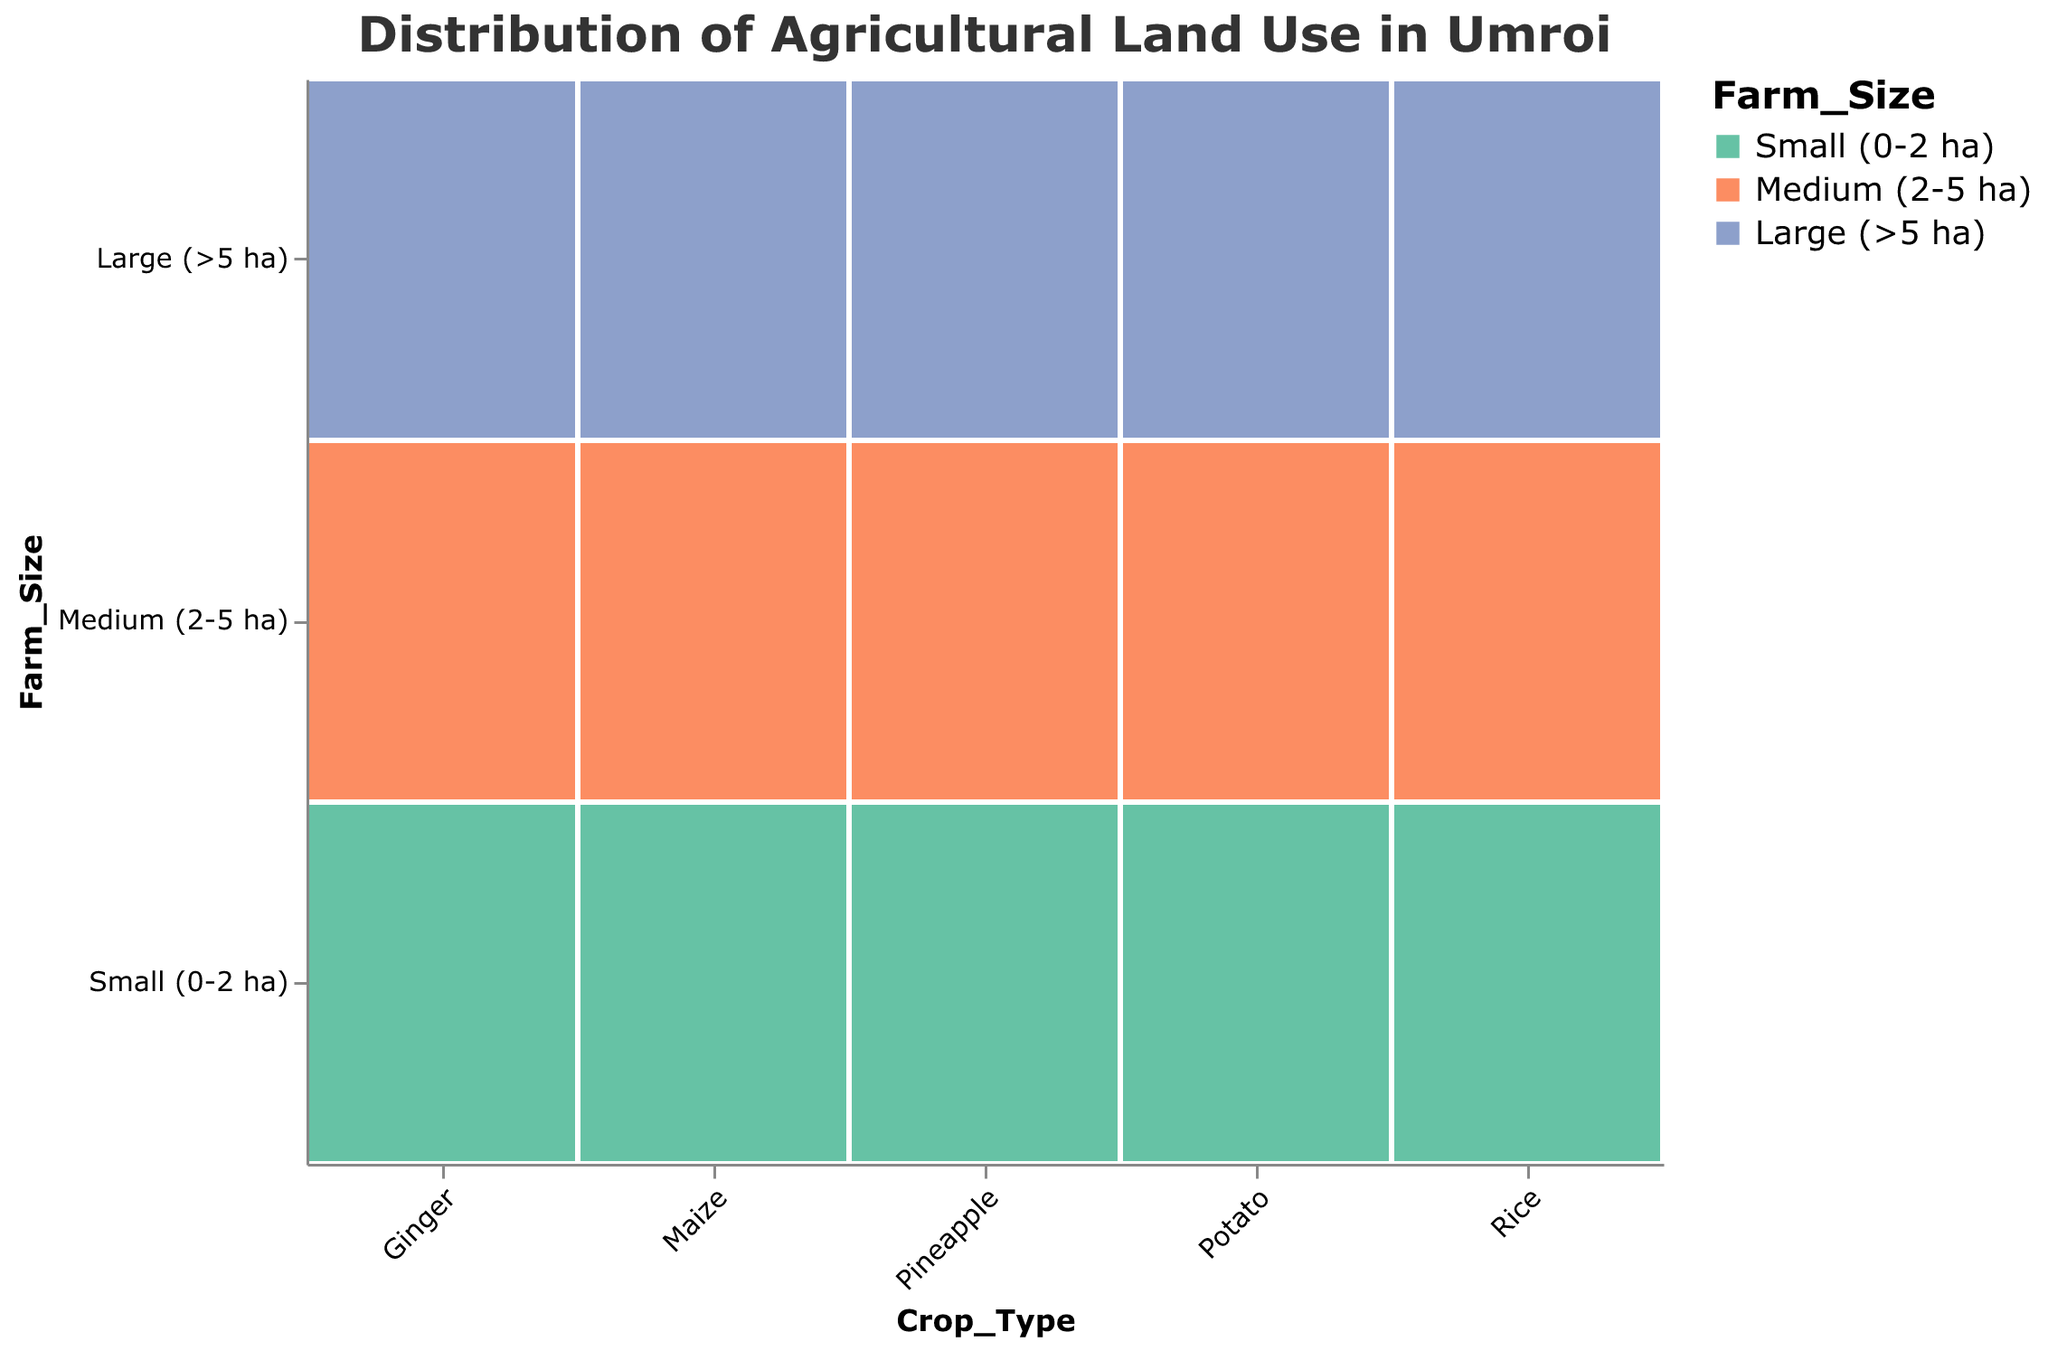What is the title of the figure? The title can be found at the top of the figure and serves to inform the viewer of the main focus of the visual representation.
Answer: Distribution of Agricultural Land Use in Umroi Which crop type has the largest area of agricultural land for small farms (0-2 ha)? By examining each crop type and the corresponding section for small farms, we see that Rice has the largest area (450 hectares).
Answer: Rice How much more area is used for medium farms (2-5 ha) compared to large farms (>5 ha) for Rice? The area used for medium farms is 680 hectares and for large farms, it is 320 hectares. Subtract 320 from 680 to get the difference.
Answer: 360 hectares Which crop type has the least area in large farms (>5 ha)? Compare the areas of large farms for all crop types and identify the smallest value. Ginger has the smallest area at 40 hectares.
Answer: Ginger What's the total area used for growing Maize across all farm sizes? Add the areas for small (180 ha), medium (240 ha), and large farms (130 ha) to get the total.
Answer: 550 hectares Which farm size category uses the maximum area for growing Ginger? Compare the areas of small, medium, and large farm sizes for Ginger. The small farm size category has the maximum area at 120 hectares.
Answer: Small (0-2 ha) Which crop type utilizes a larger area for small farms (0-2 ha) than medium farms (2-5 ha)? Examine the areas of small and medium farm sizes for each crop. Rice (450 ha vs. 680 ha) and Potato (220 ha vs. 180 ha) are the only crops having larger areas for small farms compared to medium farms. Therefore, Potato is the correct crop type.
Answer: Potato What is the total agricultural area used for Pineapple farming? Sum the areas for small (90 ha), medium (110 ha), and large farms (70 ha).
Answer: 270 hectares Rank the crop types by total area used from highest to lowest. Calculate the total area for each crop and rank them. Rice: 1450 ha, Maize: 550 ha, Potato: 490 ha, Pineapple: 270 ha, Ginger: 240 ha. Therefore, the ranking is Rice, Maize, Potato, Pineapple, Ginger.
Answer: Rice, Maize, Potato, Pineapple, Ginger Is there any crop type where large farms (>5 ha) cover more area than small farms (0-2 ha)? By examining each crop type, we observe that none of the crops has large farms covering more area than small farms. All crop types have larger or equal areas for small farms.
Answer: No 